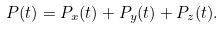Convert formula to latex. <formula><loc_0><loc_0><loc_500><loc_500>P ( t ) = P _ { x } ( t ) + P _ { y } ( t ) + P _ { z } ( t ) .</formula> 